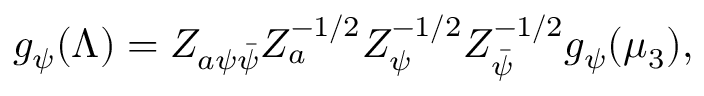Convert formula to latex. <formula><loc_0><loc_0><loc_500><loc_500>g _ { \psi } ( \Lambda ) = Z _ { a \psi \bar { \psi } } Z _ { a } ^ { - 1 / 2 } Z _ { \psi } ^ { - 1 / 2 } Z _ { \bar { \psi } } ^ { - 1 / 2 } g _ { \psi } ( \mu _ { 3 } ) ,</formula> 